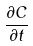<formula> <loc_0><loc_0><loc_500><loc_500>\frac { \partial C } { \partial t }</formula> 